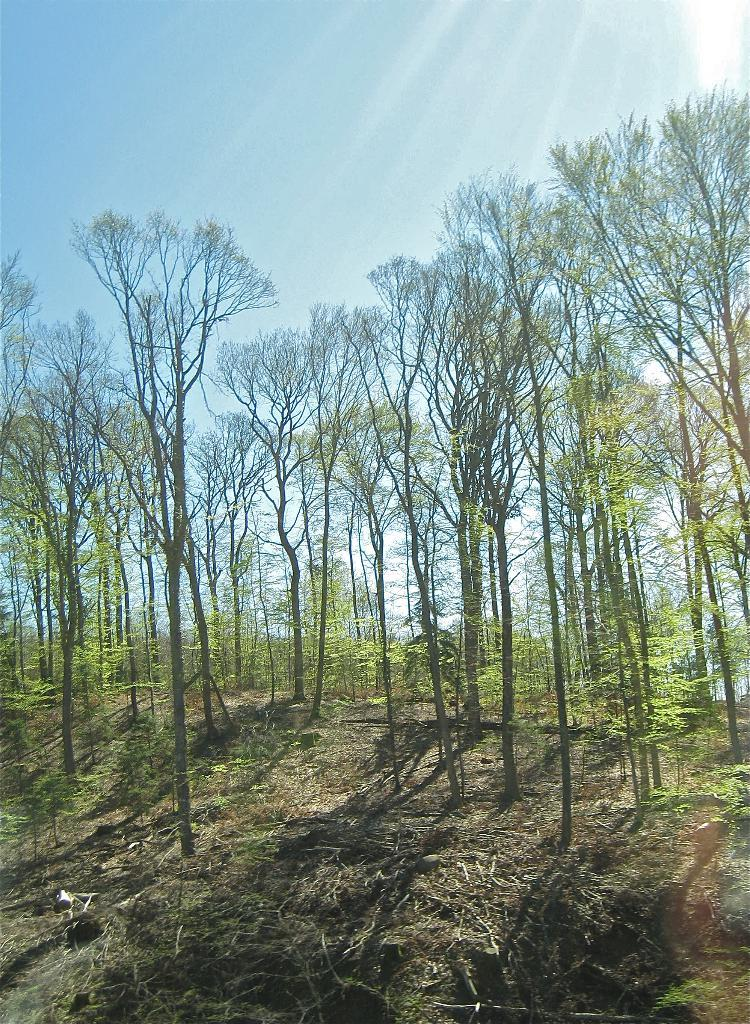What type of vegetation is present in the image? There are green color trees in the image. Where are the trees located in the image? The trees are in the middle of the image. What is visible at the top of the image? The sky is visible at the top of the image. What type of hat is hanging on the tree in the image? There is no hat present in the image; it only features green color trees and the sky. 